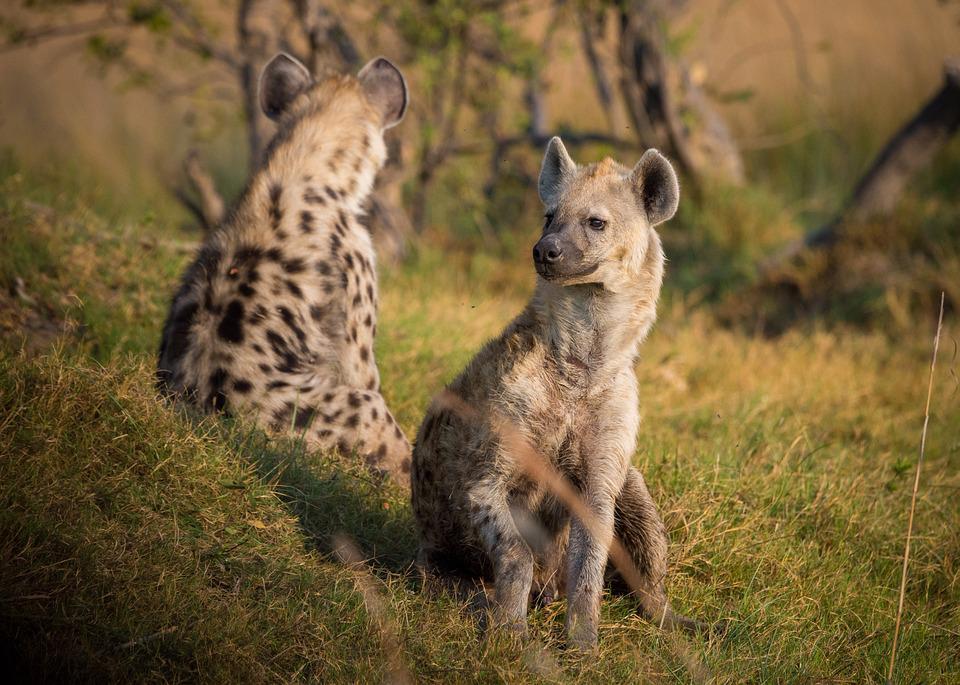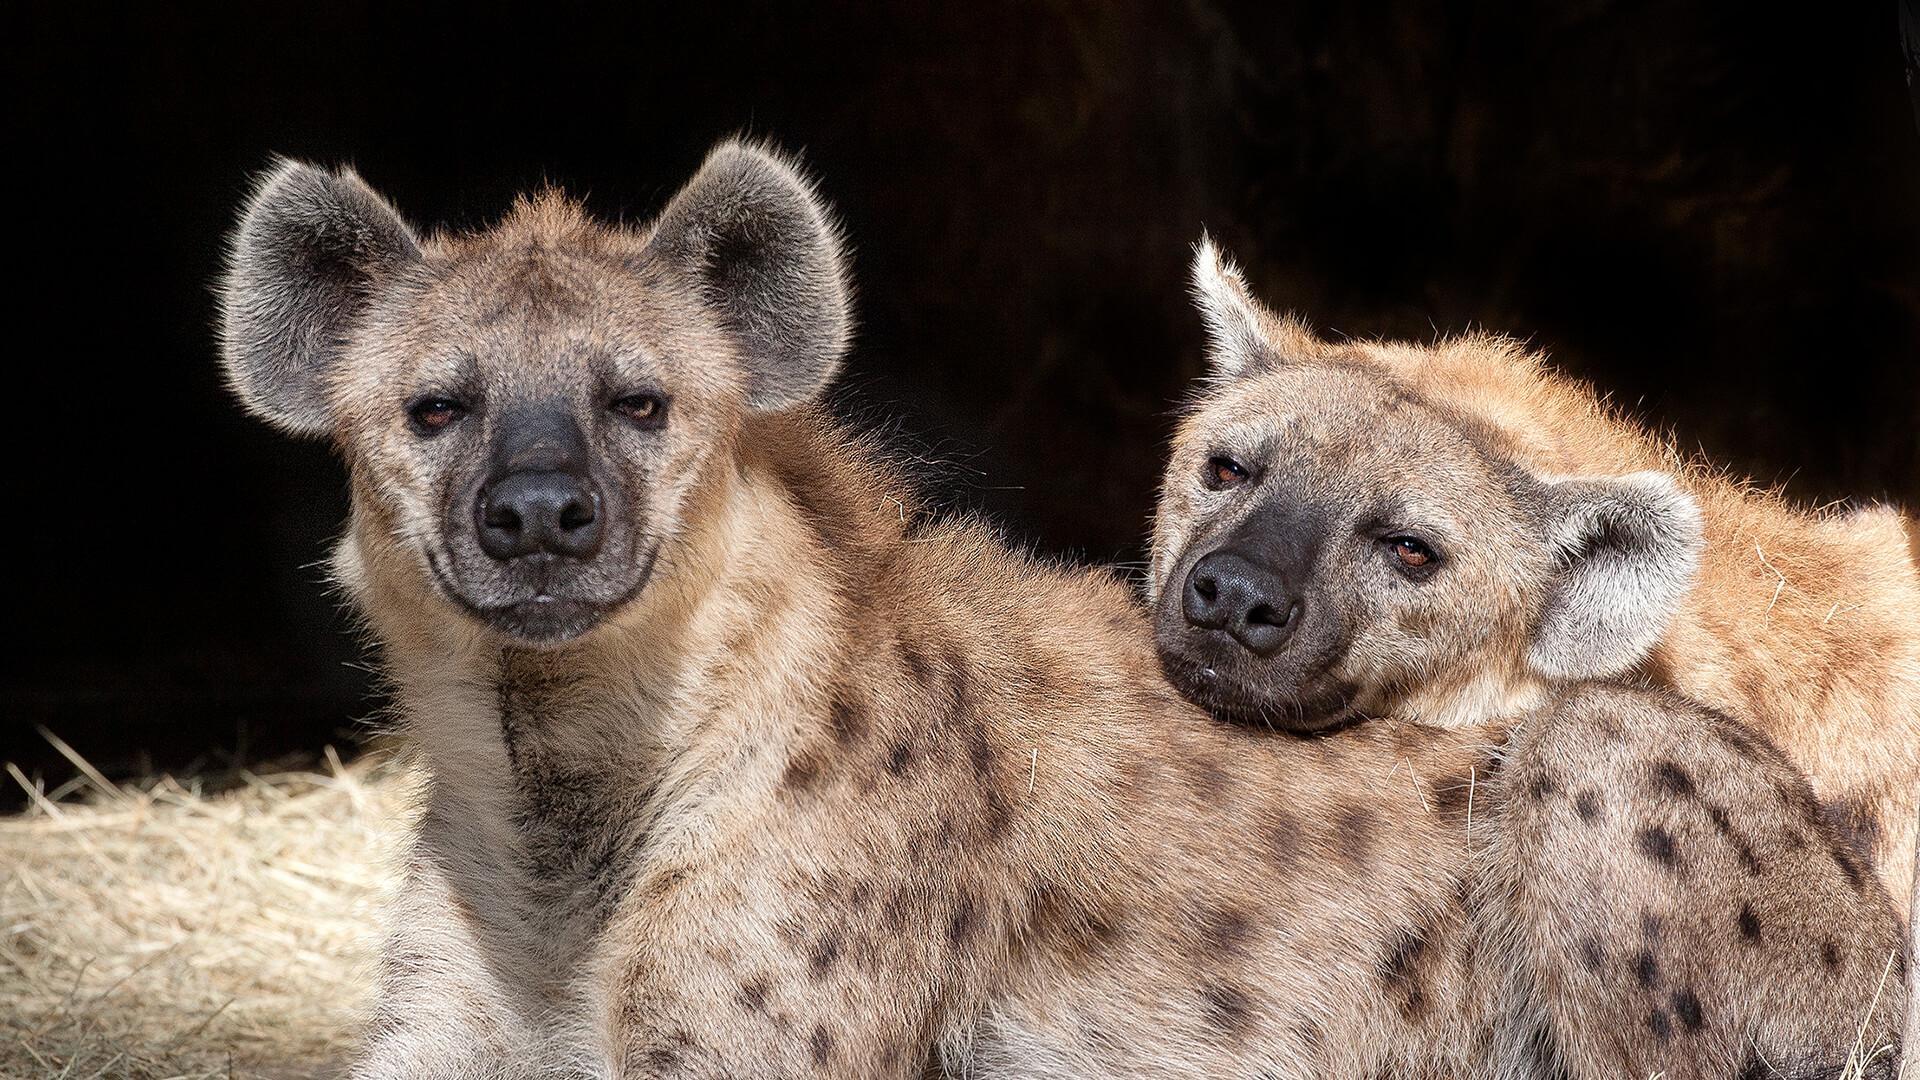The first image is the image on the left, the second image is the image on the right. Examine the images to the left and right. Is the description "There are exactly two hyenas in the image on the right." accurate? Answer yes or no. Yes. 